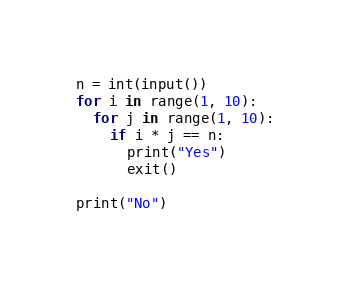Convert code to text. <code><loc_0><loc_0><loc_500><loc_500><_Python_>n = int(input())
for i in range(1, 10):
  for j in range(1, 10):
    if i * j == n:
      print("Yes")
      exit()

print("No")</code> 